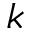Convert formula to latex. <formula><loc_0><loc_0><loc_500><loc_500>k</formula> 